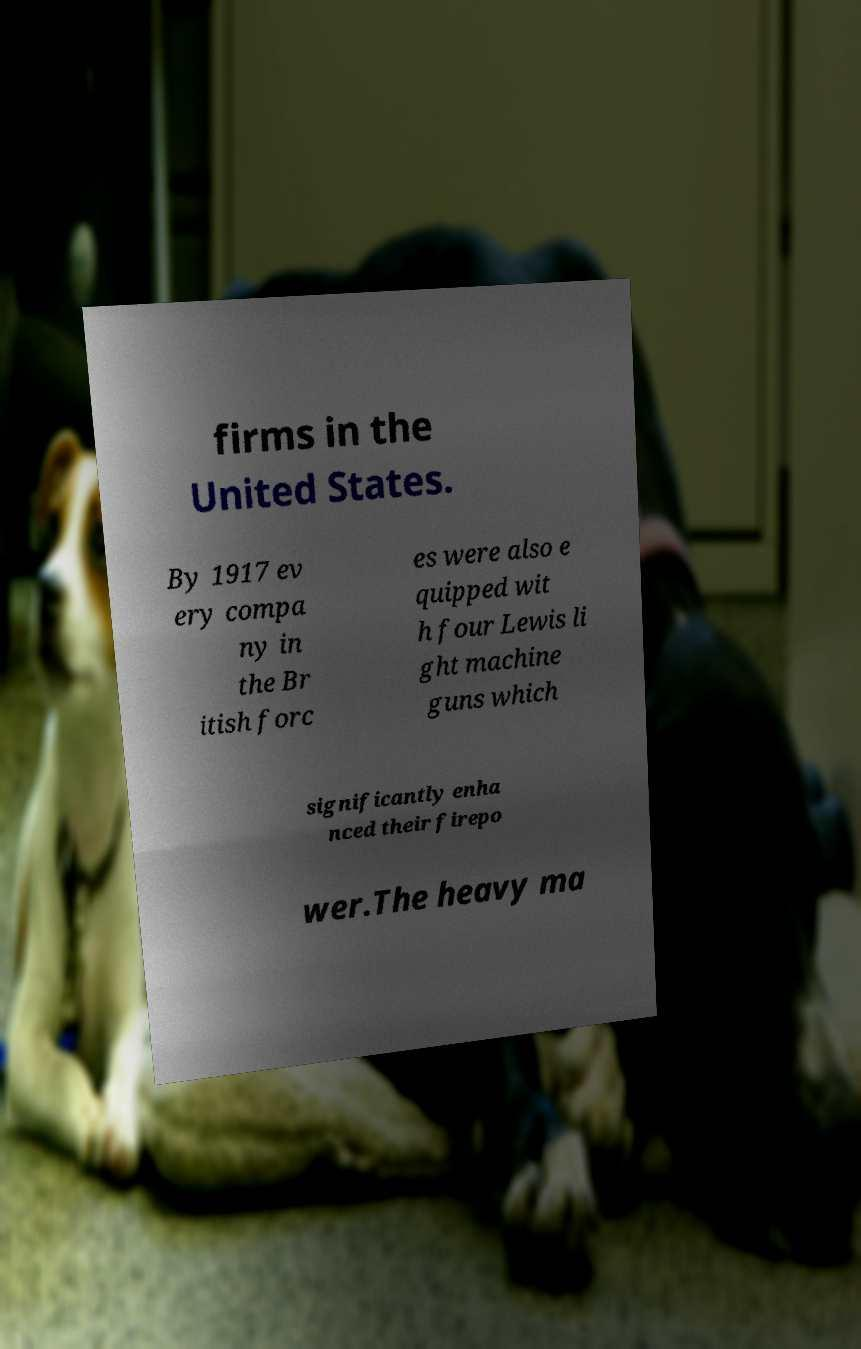I need the written content from this picture converted into text. Can you do that? firms in the United States. By 1917 ev ery compa ny in the Br itish forc es were also e quipped wit h four Lewis li ght machine guns which significantly enha nced their firepo wer.The heavy ma 